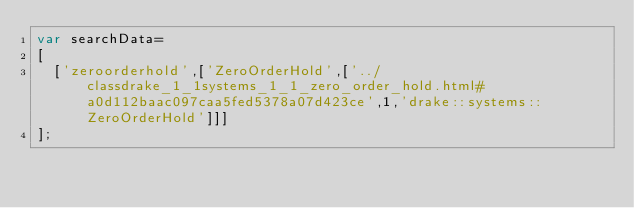<code> <loc_0><loc_0><loc_500><loc_500><_JavaScript_>var searchData=
[
  ['zeroorderhold',['ZeroOrderHold',['../classdrake_1_1systems_1_1_zero_order_hold.html#a0d112baac097caa5fed5378a07d423ce',1,'drake::systems::ZeroOrderHold']]]
];
</code> 